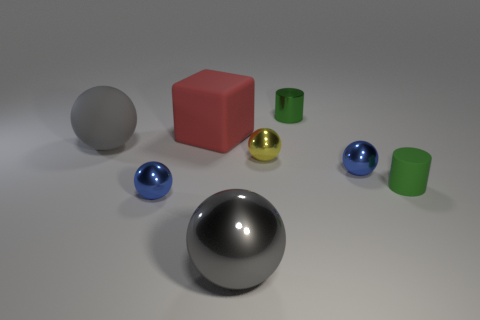The object that is the same color as the tiny rubber cylinder is what size?
Provide a succinct answer. Small. What number of large cubes are there?
Offer a terse response. 1. How many brown objects are tiny cylinders or big spheres?
Keep it short and to the point. 0. What number of other things are the same shape as the tiny yellow object?
Your answer should be compact. 4. There is a big ball that is to the left of the big gray shiny thing; does it have the same color as the large sphere in front of the small rubber object?
Make the answer very short. Yes. How many tiny things are either green metal cylinders or red matte cylinders?
Give a very brief answer. 1. What size is the other yellow metal object that is the same shape as the large metallic object?
Provide a short and direct response. Small. Is there any other thing that is the same size as the green metallic cylinder?
Make the answer very short. Yes. There is a green cylinder that is to the left of the green thing in front of the tiny yellow sphere; what is it made of?
Give a very brief answer. Metal. What number of metallic things are either red things or green cubes?
Your answer should be very brief. 0. 